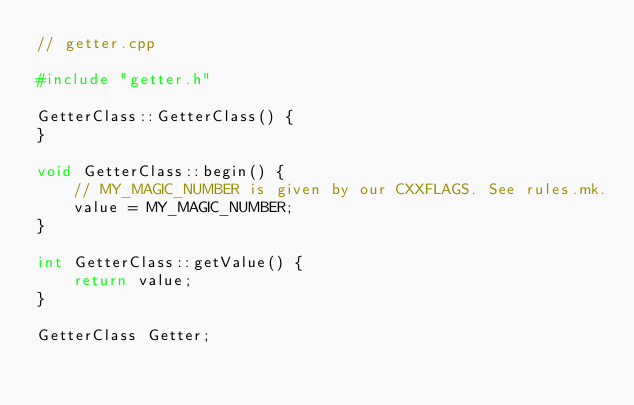<code> <loc_0><loc_0><loc_500><loc_500><_C++_>// getter.cpp

#include "getter.h"

GetterClass::GetterClass() {
}

void GetterClass::begin() {
    // MY_MAGIC_NUMBER is given by our CXXFLAGS. See rules.mk.
    value = MY_MAGIC_NUMBER;
}

int GetterClass::getValue() {
    return value;
}

GetterClass Getter;
</code> 